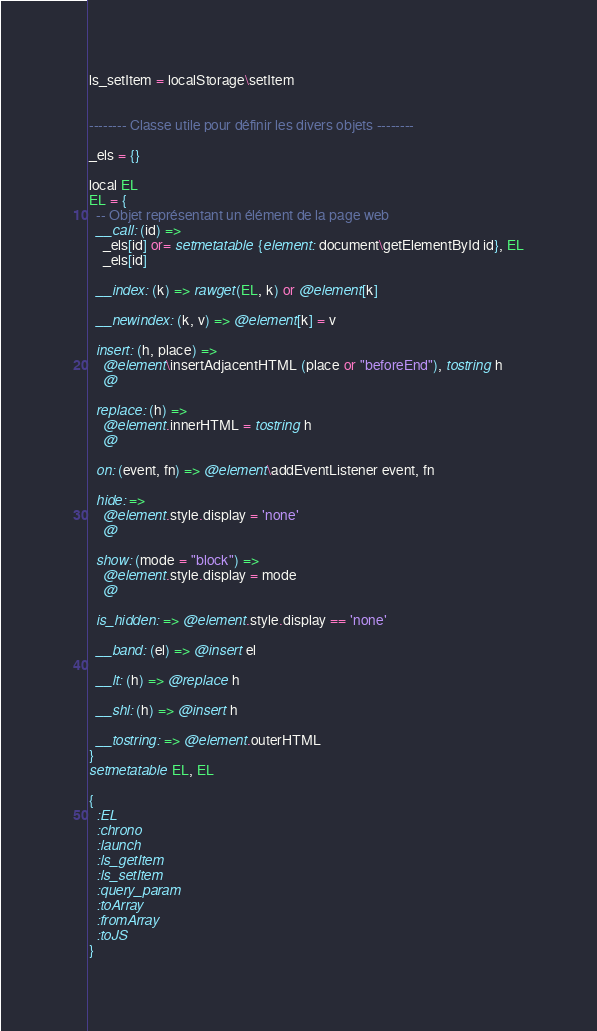<code> <loc_0><loc_0><loc_500><loc_500><_MoonScript_>
ls_setItem = localStorage\setItem


-------- Classe utile pour définir les divers objets --------

_els = {}

local EL
EL = {
  -- Objet représentant un élément de la page web
  __call: (id) =>
    _els[id] or= setmetatable {element: document\getElementById id}, EL
    _els[id]

  __index: (k) => rawget(EL, k) or @element[k]

  __newindex: (k, v) => @element[k] = v

  insert: (h, place) =>
    @element\insertAdjacentHTML (place or "beforeEnd"), tostring h
    @

  replace: (h) =>
    @element.innerHTML = tostring h
    @

  on: (event, fn) => @element\addEventListener event, fn

  hide: =>
    @element.style.display = 'none'
    @

  show: (mode = "block") =>
    @element.style.display = mode
    @

  is_hidden: => @element.style.display == 'none'

  __band: (el) => @insert el

  __lt: (h) => @replace h

  __shl: (h) => @insert h

  __tostring: => @element.outerHTML
}
setmetatable EL, EL

{
  :EL
  :chrono
  :launch
  :ls_getItem
  :ls_setItem
  :query_param
  :toArray
  :fromArray
  :toJS
}</code> 